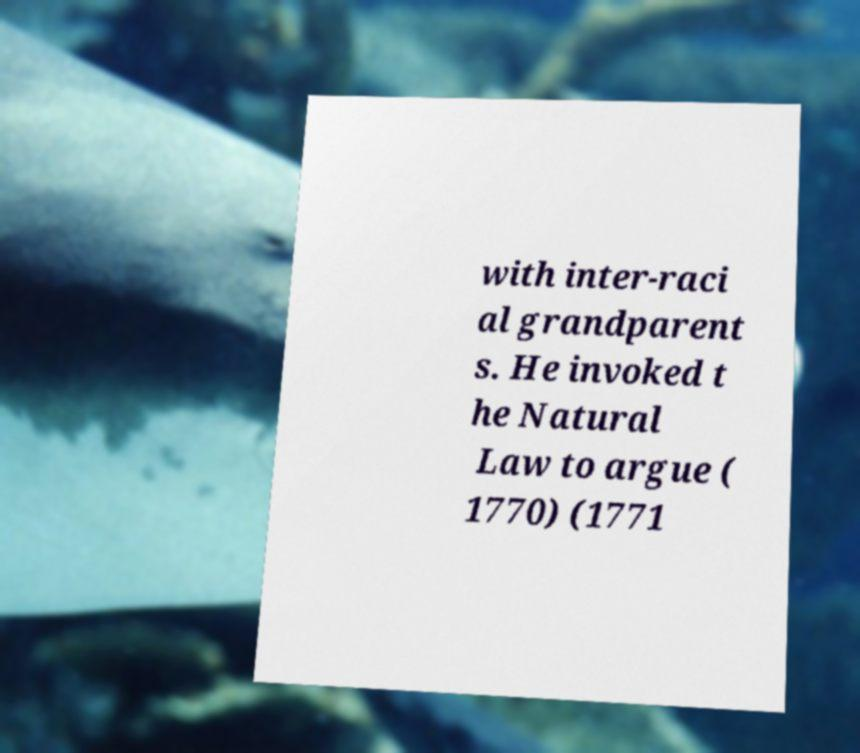Can you read and provide the text displayed in the image?This photo seems to have some interesting text. Can you extract and type it out for me? with inter-raci al grandparent s. He invoked t he Natural Law to argue ( 1770) (1771 